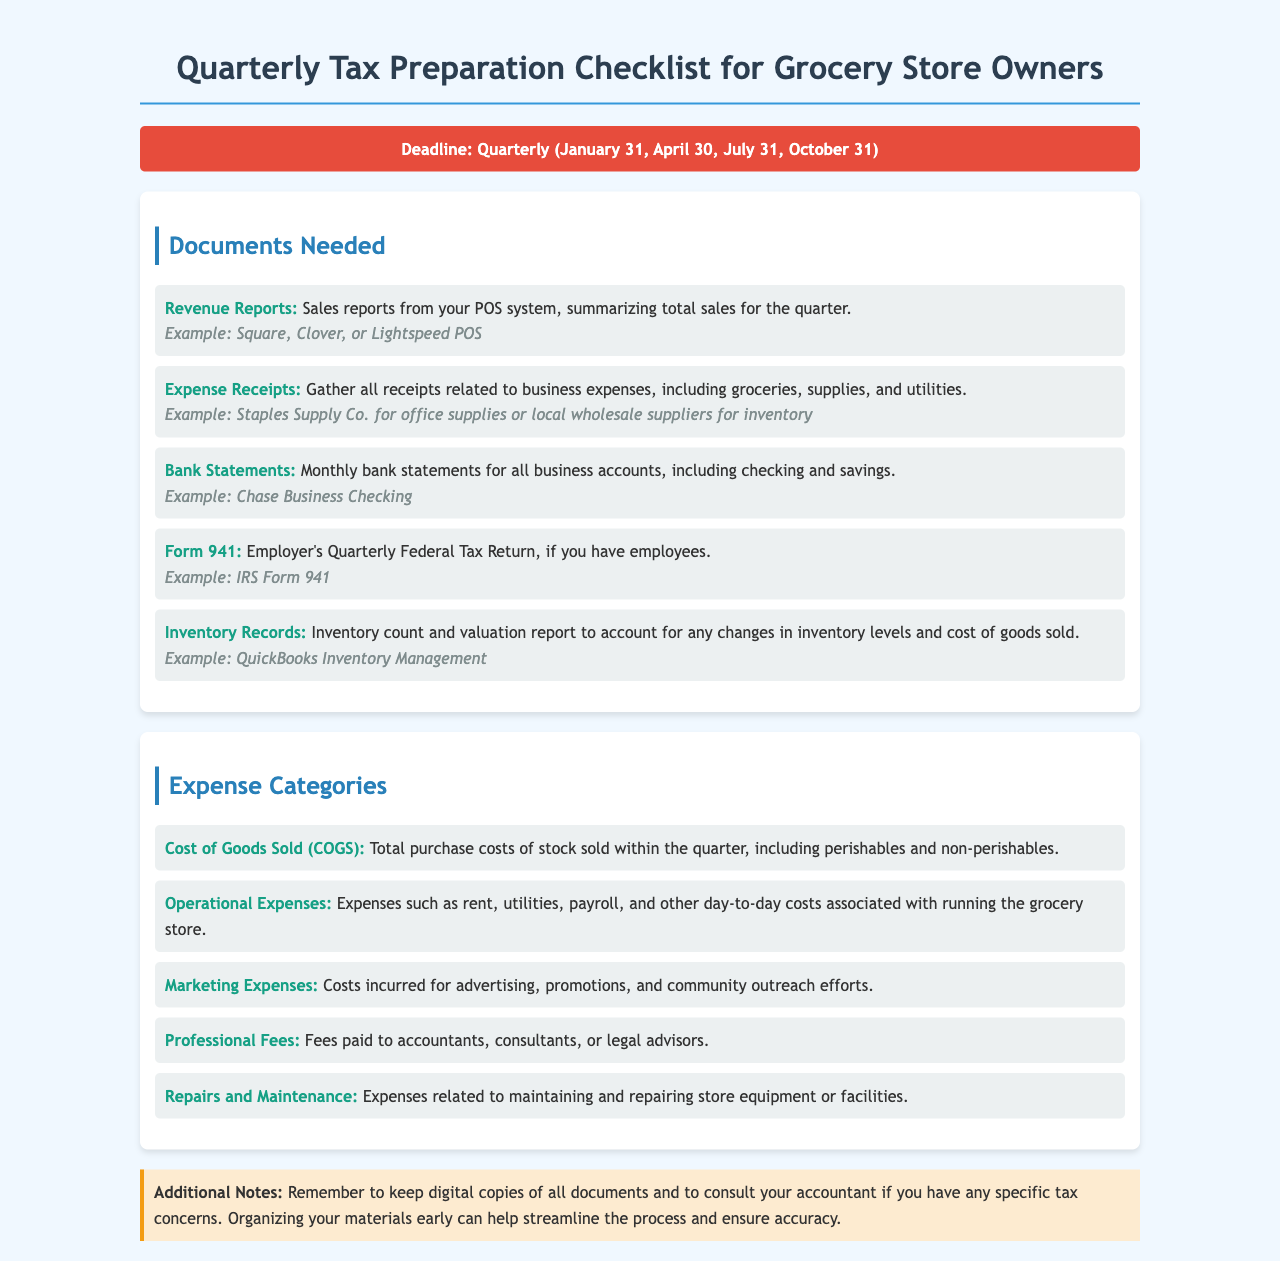What is the deadline for quarterly tax preparation? The document specifies that the deadlines for quarterly tax preparation are January 31, April 30, July 31, and October 31.
Answer: January 31, April 30, July 31, October 31 What types of reports are needed for tax preparation? The document lists several report types necessary for tax preparation, including Revenue Reports, Expense Receipts, and Bank Statements.
Answer: Revenue Reports, Expense Receipts, Bank Statements Which form is required if I have employees? The document states that Form 941 is necessary for employers with employees.
Answer: Form 941 What is one expense category mentioned in the document? The document outlines several expense categories, such as Cost of Goods Sold, Operational Expenses, and Marketing Expenses.
Answer: Cost of Goods Sold What example is given for bank statements? The document provides Chase Business Checking as an example of a bank statement for business accounts.
Answer: Chase Business Checking What type of expenses does the category 'Repairs and Maintenance' include? The document explains that Repairs and Maintenance includes expenses for maintaining and repairing store equipment or facilities.
Answer: Maintaining and repairing store equipment or facilities What additional documents should be kept digitally? The document advises to keep digital copies of all necessary documents for tax preparation.
Answer: All documents What is the purpose of gathering Inventory Records? The document states that Inventory Records account for changes in inventory levels and cost of goods sold.
Answer: Account for changes in inventory levels and cost of goods sold 